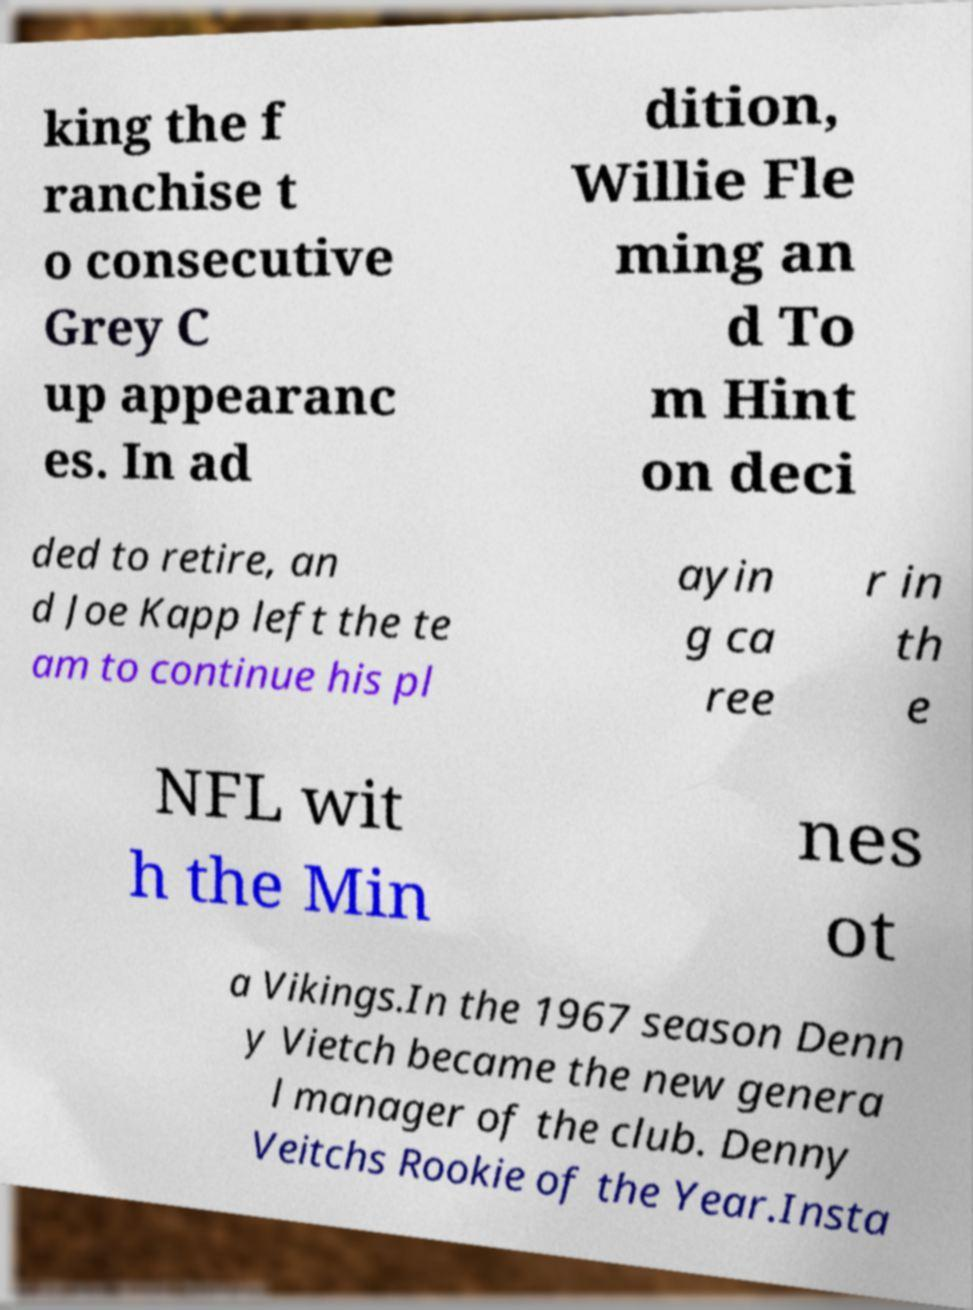Can you read and provide the text displayed in the image?This photo seems to have some interesting text. Can you extract and type it out for me? king the f ranchise t o consecutive Grey C up appearanc es. In ad dition, Willie Fle ming an d To m Hint on deci ded to retire, an d Joe Kapp left the te am to continue his pl ayin g ca ree r in th e NFL wit h the Min nes ot a Vikings.In the 1967 season Denn y Vietch became the new genera l manager of the club. Denny Veitchs Rookie of the Year.Insta 